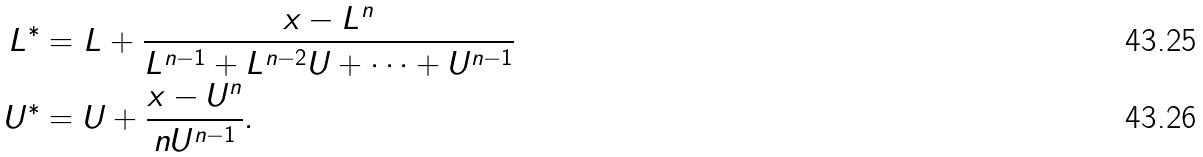<formula> <loc_0><loc_0><loc_500><loc_500>L ^ { \ast } & = L + \frac { x - L ^ { n } } { L ^ { n - 1 } + L ^ { n - 2 } U + \cdots + U ^ { n - 1 } } \\ U ^ { \ast } & = U + \frac { x - U ^ { n } } { n U ^ { n - 1 } } .</formula> 